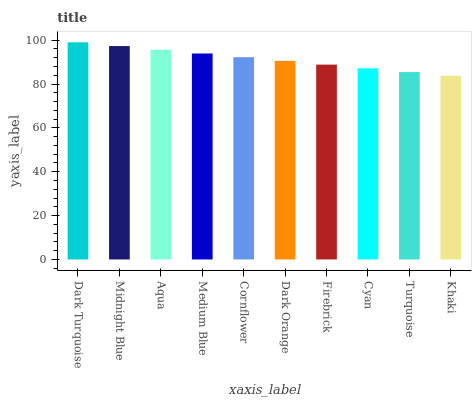Is Midnight Blue the minimum?
Answer yes or no. No. Is Midnight Blue the maximum?
Answer yes or no. No. Is Dark Turquoise greater than Midnight Blue?
Answer yes or no. Yes. Is Midnight Blue less than Dark Turquoise?
Answer yes or no. Yes. Is Midnight Blue greater than Dark Turquoise?
Answer yes or no. No. Is Dark Turquoise less than Midnight Blue?
Answer yes or no. No. Is Cornflower the high median?
Answer yes or no. Yes. Is Dark Orange the low median?
Answer yes or no. Yes. Is Midnight Blue the high median?
Answer yes or no. No. Is Midnight Blue the low median?
Answer yes or no. No. 